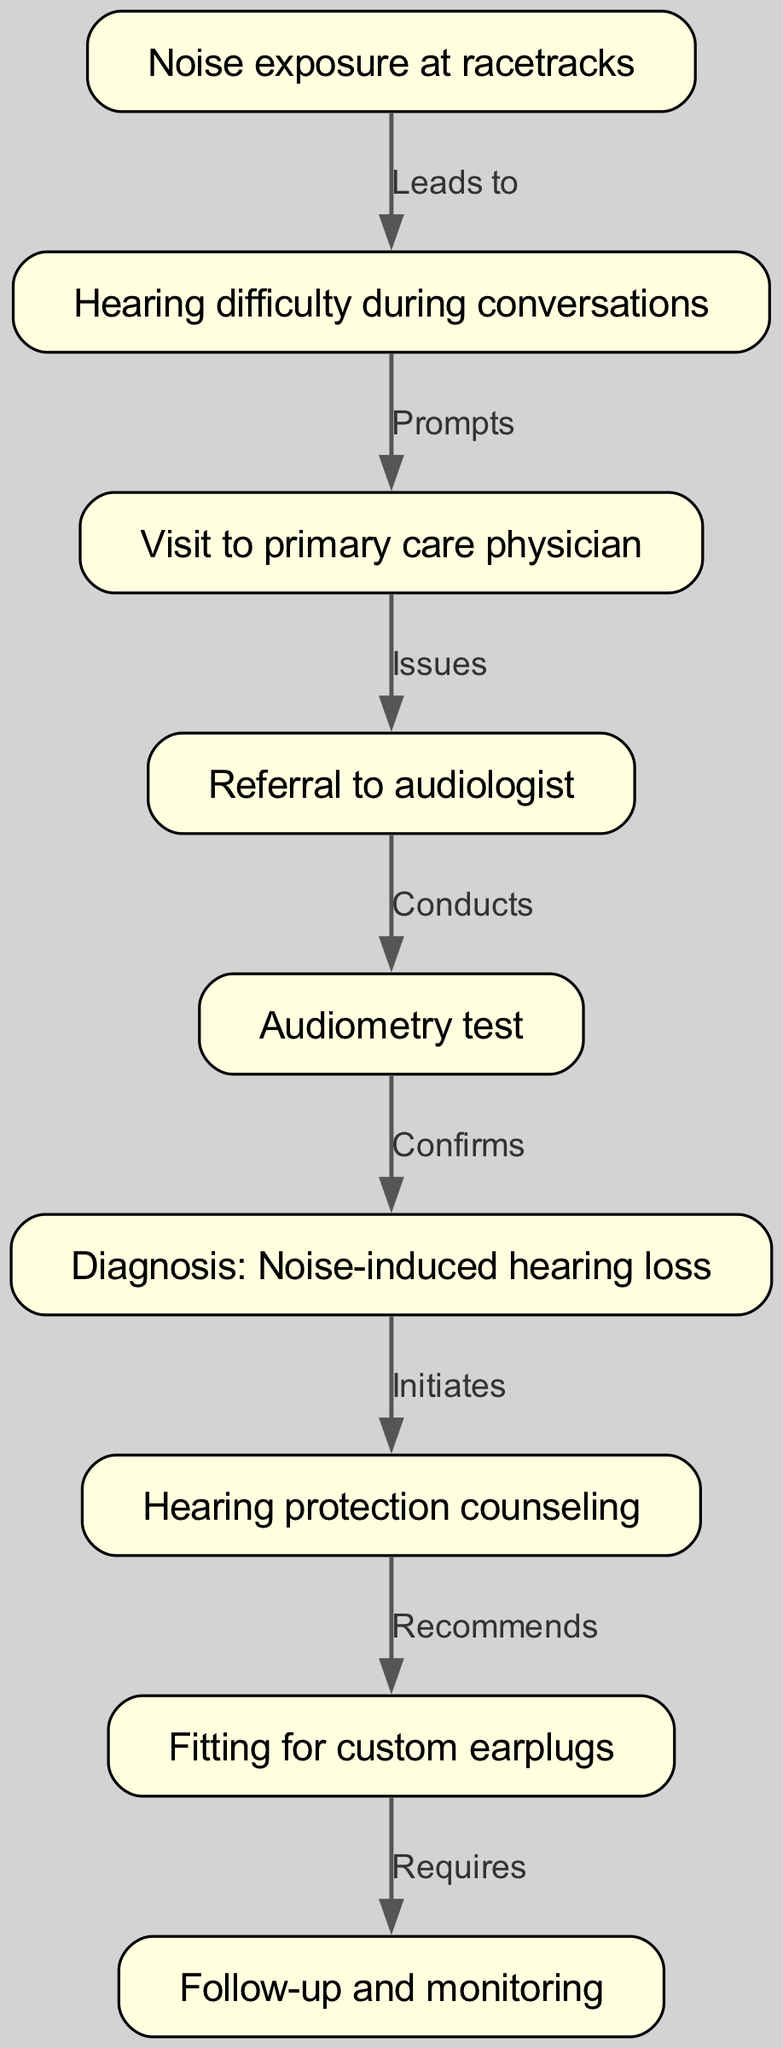What leads to hearing difficulty during conversations? The diagram shows that noise exposure at racetracks leads to hearing difficulty during conversations. Specifically, the edge indicates a direct causal relationship.
Answer: Noise exposure at racetracks What is the second step after experiencing hearing difficulty? According to the diagram, after experiencing hearing difficulty during conversations, the next step is to visit a primary care physician. This is shown as a prompting action following the hearing difficulty.
Answer: Visit to primary care physician How many nodes are there in total? By counting the nodes listed in the diagram, there are nine distinct nodes outlining various steps and elements in the clinical pathway related to noise-induced hearing loss.
Answer: 9 What does the audiologist conduct? The diagram indicates that the audiologist conducts an audiometry test following the referral from the primary care physician. This means that the audiologist performs a specific examination related to hearing.
Answer: Audiometry test What is required after fitting for custom earplugs? The diagram illustrates that follow-up and monitoring are required after fitting for custom earplugs, indicating that this is an essential step to ensure ongoing evaluation of hearing protection effectiveness.
Answer: Follow-up and monitoring What initiates hearing protection counseling? The diagnosis of noise-induced hearing loss initiates hearing protection counseling, as shown in the diagram. This indicates that after confirming the diagnosis, the patient is advised on how to protect their hearing.
Answer: Hearing protection counseling What prompts a visit to the primary care physician? The hearing difficulty during conversations prompts a visit to the primary care physician according to the relationship shown in the diagram. This represents a cause-effect relationship leading to seeking medical advice.
Answer: Hearing difficulty during conversations What relationship is shown between referral to audiologist and audiometry test? The diagram indicates that the referral to an audiologist conducts an audiometry test, which means that the action of referring directly leads to the performance of the test by the audiologist.
Answer: Conducts 